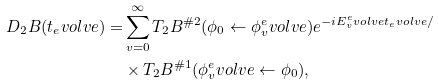Convert formula to latex. <formula><loc_0><loc_0><loc_500><loc_500>D _ { 2 } B ( t _ { e } v o l v e ) = & \sum _ { v = 0 } ^ { \infty } T _ { 2 } B ^ { \# 2 } ( \phi _ { 0 } \leftarrow \phi _ { v } ^ { e } v o l v e ) e ^ { - i E _ { v } ^ { e } v o l v e t _ { e } v o l v e / } \\ & \times T _ { 2 } B ^ { \# 1 } ( \phi _ { v } ^ { e } v o l v e \leftarrow \phi _ { 0 } ) ,</formula> 